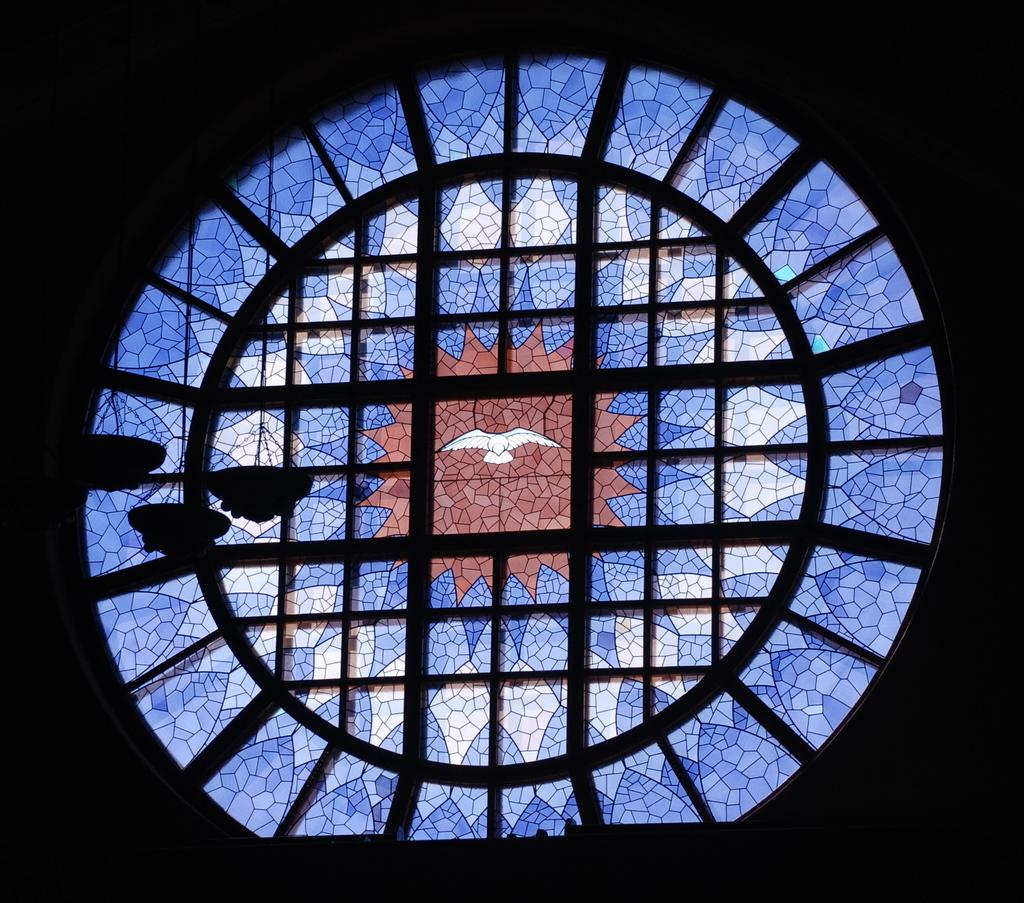What is located in the center of the image? There is a glass window in the center of the image. What is depicted on the glass window? There is some art on the window. What type of structure can be seen in the image? There is a fence in the image. What type of ink is used to create the art on the glass window? There is no information about the type of ink used to create the art on the glass window, as it is not mentioned in the facts provided. 